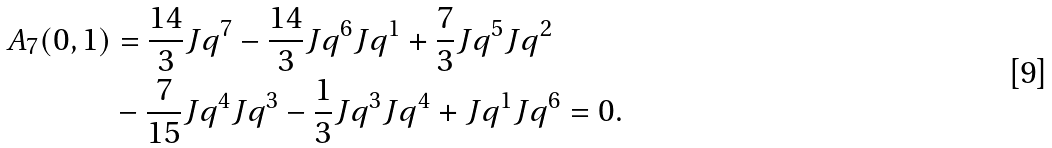Convert formula to latex. <formula><loc_0><loc_0><loc_500><loc_500>A _ { 7 } ( 0 , 1 ) & = \frac { 1 4 } { 3 } J q ^ { 7 } - \frac { 1 4 } { 3 } J q ^ { 6 } J q ^ { 1 } + \frac { 7 } { 3 } J q ^ { 5 } J q ^ { 2 } \\ & - \frac { 7 } { 1 5 } J q ^ { 4 } J q ^ { 3 } - \frac { 1 } { 3 } J q ^ { 3 } J q ^ { 4 } + J q ^ { 1 } J q ^ { 6 } = 0 .</formula> 